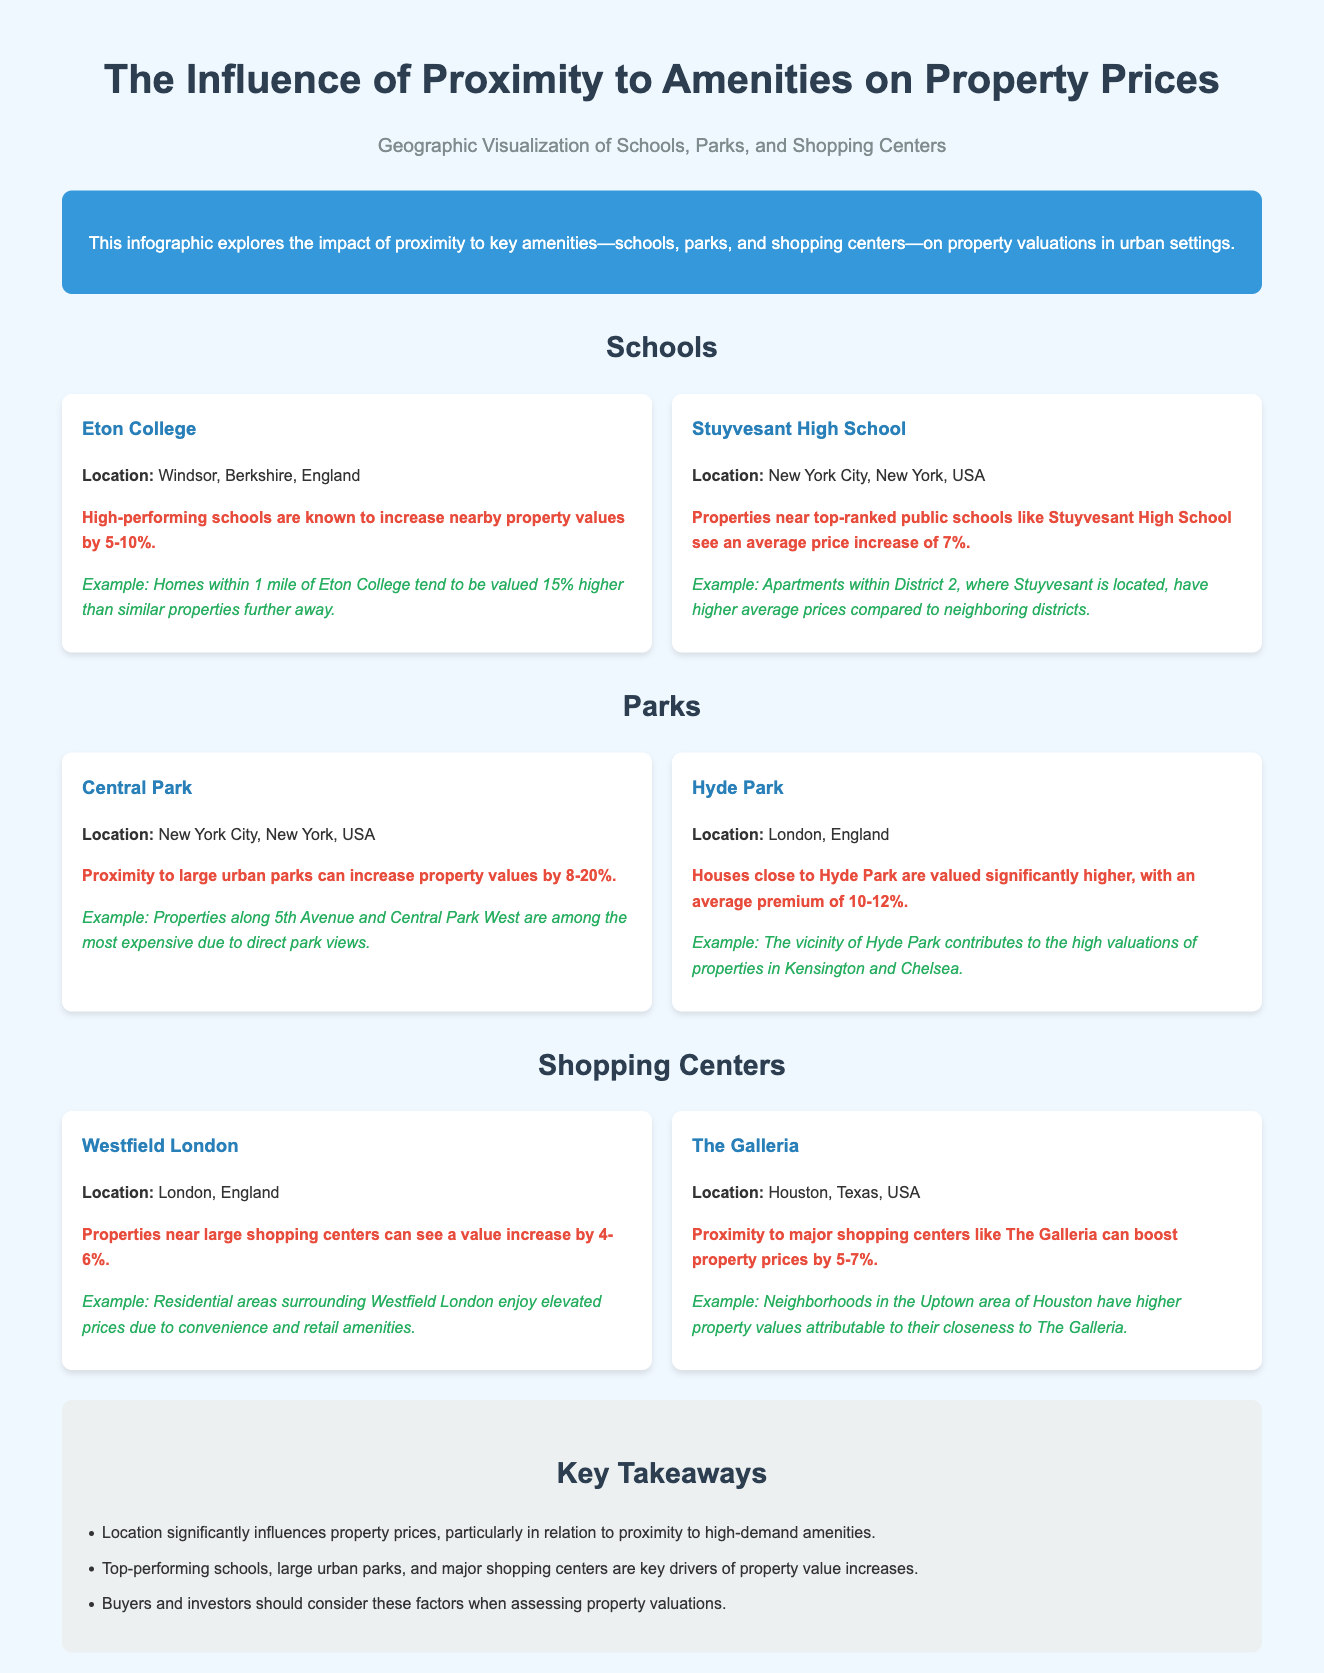what is the title of the infographic? The title of the infographic is presented prominently at the top of the document.
Answer: The Influence of Proximity to Amenities on Property Prices which school is located in Windsor, Berkshire, England? The document provides the names and locations of specific schools.
Answer: Eton College how much can high-performing schools increase nearby property values by? This information is found in the section discussing the impact of schools on property prices.
Answer: 5-10% what is the average price increase for properties near Stuyvesant High School? The document specifies the average price increase for properties near this school.
Answer: 7% how much can proximity to large urban parks increase property values by? This information is mentioned in the parks section of the infographic.
Answer: 8-20% in which city is The Galleria located? The location of The Galleria is stated in the context of shopping centers.
Answer: Houston which park contributes to high valuations in Kensington and Chelsea? The document mentions parks and their associations with property values.
Answer: Hyde Park what is a key takeaway regarding property prices? The section on key takeaways summarizes the overall findings related to property valuation.
Answer: Location significantly influences property prices how does proximity to shopping centers generally affect property values? This information is covered in the shopping centers area of the infographic.
Answer: 4-6% 